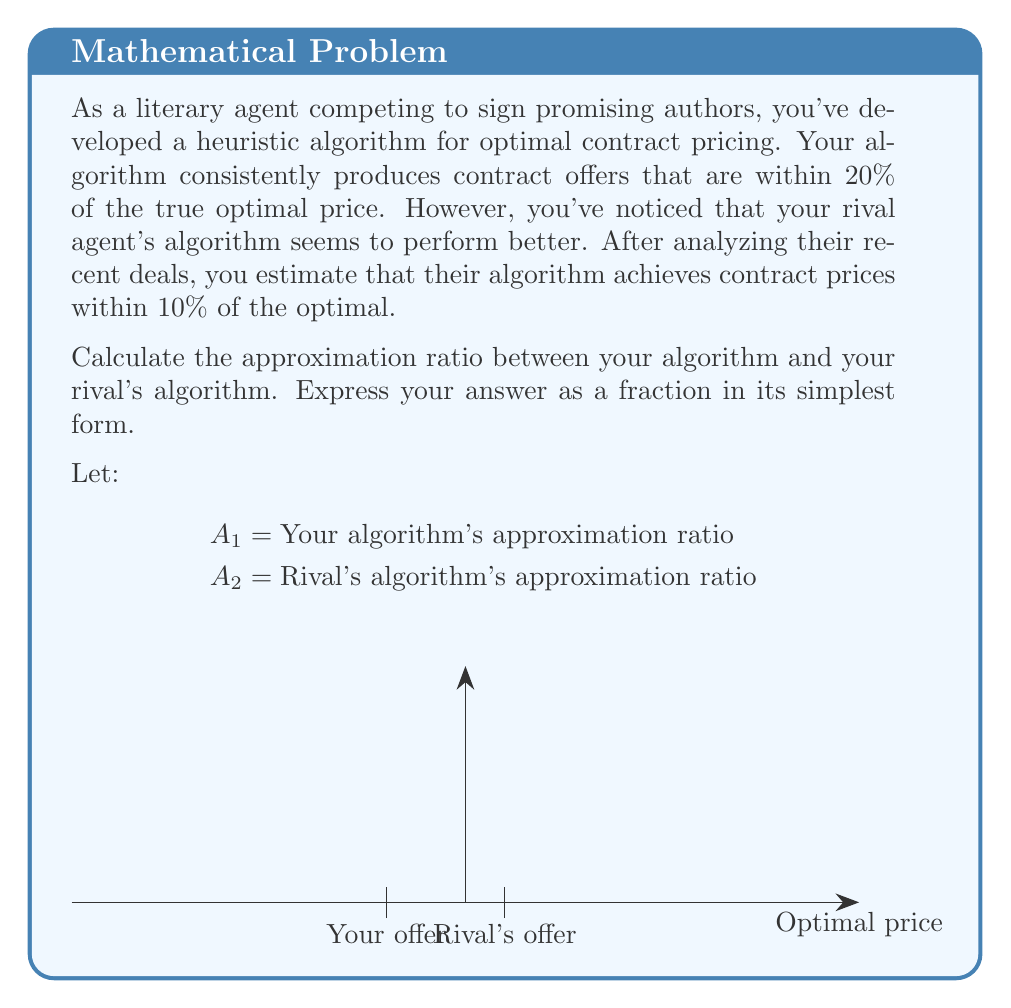What is the answer to this math problem? To solve this problem, we need to follow these steps:

1) First, let's define the approximation ratios:
   Your algorithm: $A_1 = 1.20$ (within 20% of optimal)
   Rival's algorithm: $A_2 = 1.10$ (within 10% of optimal)

2) The approximation ratio between your algorithm and your rival's is the ratio of these two ratios:

   $$\frac{A_1}{A_2} = \frac{1.20}{1.10}$$

3) To simplify this fraction:
   $$\frac{1.20}{1.10} = \frac{120}{110}$$

4) We can divide both numerator and denominator by their greatest common divisor (GCD):
   GCD(120, 110) = 10

   $$\frac{120}{110} = \frac{120 \div 10}{110 \div 10} = \frac{12}{11}$$

Thus, the approximation ratio between your algorithm and your rival's algorithm is 12:11.
Answer: $\frac{12}{11}$ 